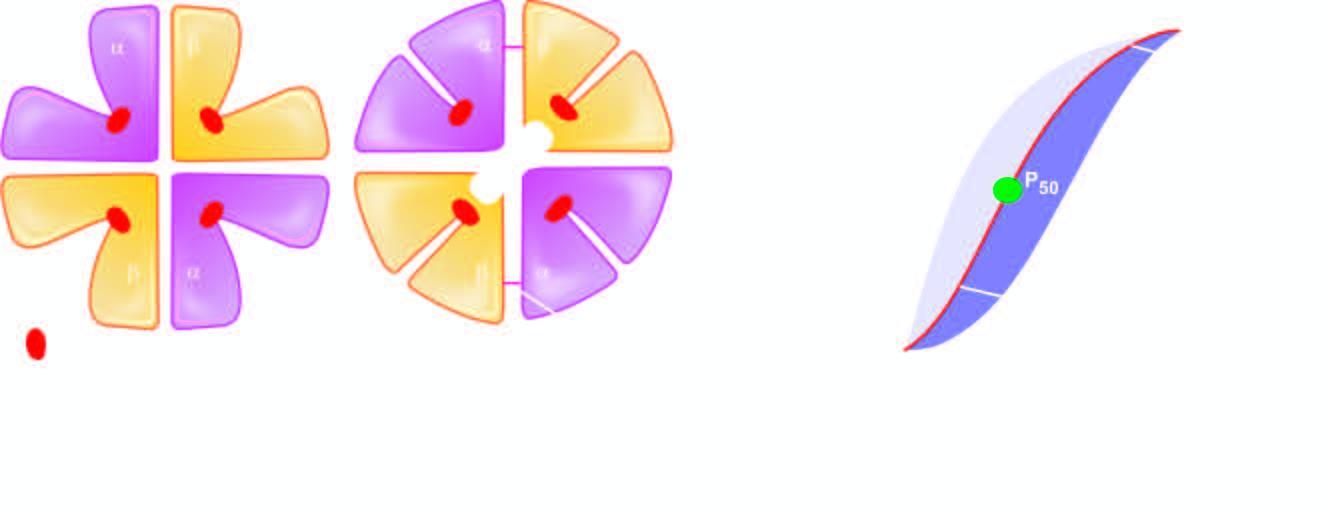re salt bridges broken?
Answer the question using a single word or phrase. Yes 